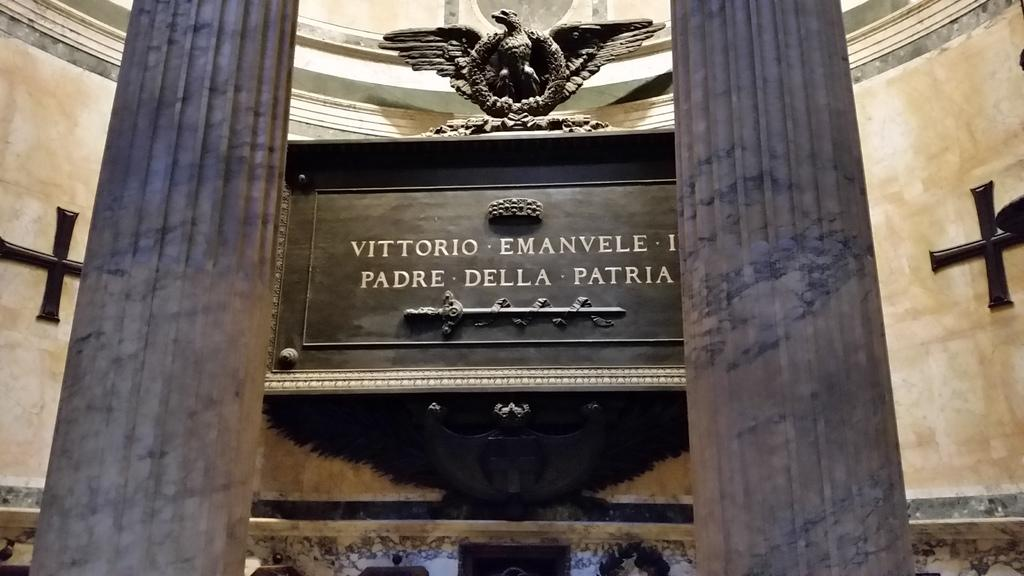What type of space is shown in the image? The image is an inside view of a room. What decorative or artistic elements can be seen in the room? There are sculptures in the room. What surface might be used for displaying information or artwork in the room? There is a board in the room. What architectural features support the structure of the room? There are pillars in the room. What encloses the space and provides privacy in the room? There are walls in the room. How many ants can be seen crawling on the skirt in the image? There is no skirt or ants present in the image; it is an inside view of a room with sculptures, a board, pillars, and walls. 